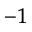<formula> <loc_0><loc_0><loc_500><loc_500>^ { - 1 }</formula> 